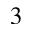<formula> <loc_0><loc_0><loc_500><loc_500>^ { 3 }</formula> 